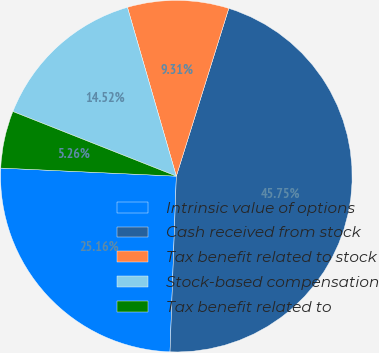Convert chart. <chart><loc_0><loc_0><loc_500><loc_500><pie_chart><fcel>Intrinsic value of options<fcel>Cash received from stock<fcel>Tax benefit related to stock<fcel>Stock-based compensation<fcel>Tax benefit related to<nl><fcel>25.16%<fcel>45.75%<fcel>9.31%<fcel>14.52%<fcel>5.26%<nl></chart> 